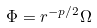<formula> <loc_0><loc_0><loc_500><loc_500>\Phi = r ^ { - p / 2 } \Omega</formula> 